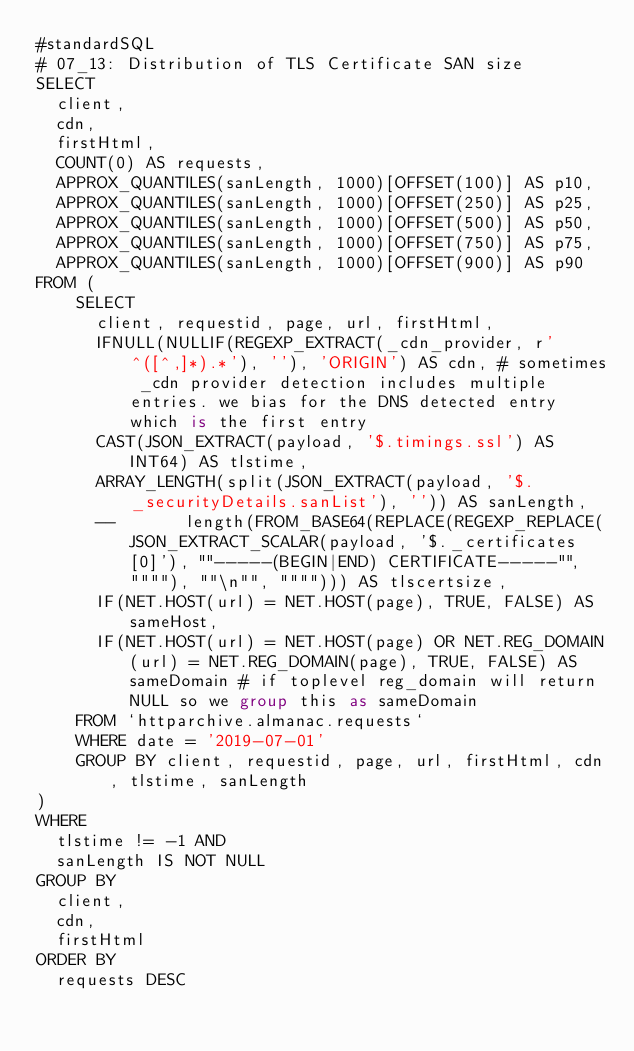Convert code to text. <code><loc_0><loc_0><loc_500><loc_500><_SQL_>#standardSQL
# 07_13: Distribution of TLS Certificate SAN size
SELECT
  client,
  cdn,
  firstHtml,
  COUNT(0) AS requests,
  APPROX_QUANTILES(sanLength, 1000)[OFFSET(100)] AS p10,
  APPROX_QUANTILES(sanLength, 1000)[OFFSET(250)] AS p25,
  APPROX_QUANTILES(sanLength, 1000)[OFFSET(500)] AS p50,
  APPROX_QUANTILES(sanLength, 1000)[OFFSET(750)] AS p75,
  APPROX_QUANTILES(sanLength, 1000)[OFFSET(900)] AS p90
FROM (
    SELECT
      client, requestid, page, url, firstHtml,
      IFNULL(NULLIF(REGEXP_EXTRACT(_cdn_provider, r'^([^,]*).*'), ''), 'ORIGIN') AS cdn, # sometimes _cdn provider detection includes multiple entries. we bias for the DNS detected entry which is the first entry
      CAST(JSON_EXTRACT(payload, '$.timings.ssl') AS INT64) AS tlstime,
      ARRAY_LENGTH(split(JSON_EXTRACT(payload, '$._securityDetails.sanList'), '')) AS sanLength,
      --       length(FROM_BASE64(REPLACE(REGEXP_REPLACE(JSON_EXTRACT_SCALAR(payload, '$._certificates[0]'), ""-----(BEGIN|END) CERTIFICATE-----"", """"), ""\n"", """"))) AS tlscertsize,
      IF(NET.HOST(url) = NET.HOST(page), TRUE, FALSE) AS sameHost,
      IF(NET.HOST(url) = NET.HOST(page) OR NET.REG_DOMAIN(url) = NET.REG_DOMAIN(page), TRUE, FALSE) AS sameDomain # if toplevel reg_domain will return NULL so we group this as sameDomain
    FROM `httparchive.almanac.requests`
    WHERE date = '2019-07-01'
    GROUP BY client, requestid, page, url, firstHtml, cdn, tlstime, sanLength
)
WHERE
  tlstime != -1 AND
  sanLength IS NOT NULL
GROUP BY
  client,
  cdn,
  firstHtml
ORDER BY
  requests DESC
</code> 